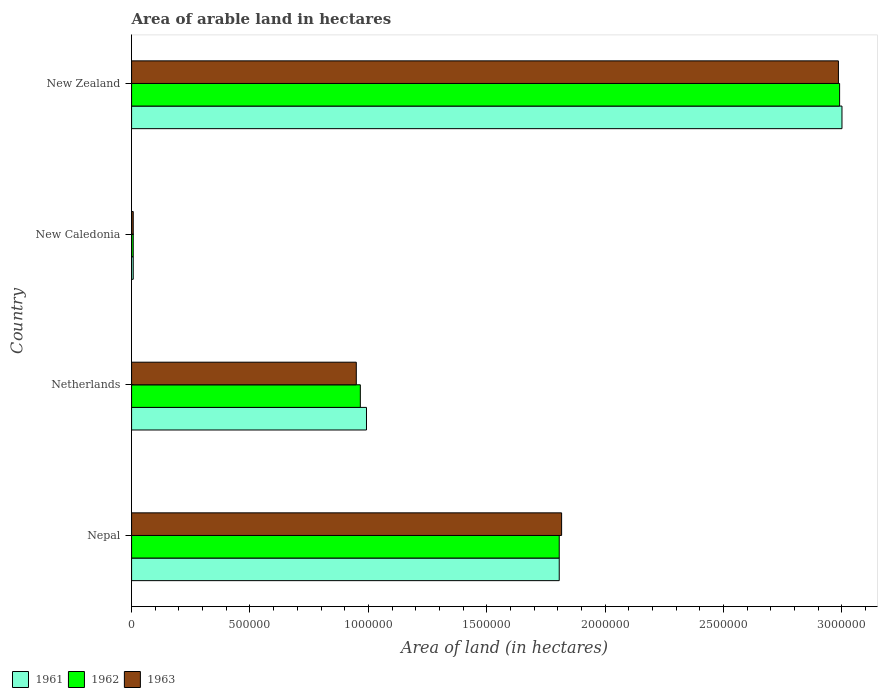What is the label of the 2nd group of bars from the top?
Give a very brief answer. New Caledonia. In how many cases, is the number of bars for a given country not equal to the number of legend labels?
Ensure brevity in your answer.  0. What is the total arable land in 1963 in Nepal?
Your response must be concise. 1.82e+06. Across all countries, what is the minimum total arable land in 1962?
Offer a very short reply. 7000. In which country was the total arable land in 1963 maximum?
Give a very brief answer. New Zealand. In which country was the total arable land in 1963 minimum?
Ensure brevity in your answer.  New Caledonia. What is the total total arable land in 1963 in the graph?
Provide a succinct answer. 5.76e+06. What is the difference between the total arable land in 1962 in Nepal and that in New Zealand?
Your answer should be compact. -1.18e+06. What is the difference between the total arable land in 1963 in Netherlands and the total arable land in 1961 in New Caledonia?
Keep it short and to the point. 9.42e+05. What is the average total arable land in 1962 per country?
Your answer should be very brief. 1.44e+06. What is the difference between the total arable land in 1961 and total arable land in 1963 in Nepal?
Keep it short and to the point. -10000. What is the ratio of the total arable land in 1963 in Netherlands to that in New Caledonia?
Keep it short and to the point. 135.57. Is the total arable land in 1963 in New Caledonia less than that in New Zealand?
Offer a terse response. Yes. What is the difference between the highest and the second highest total arable land in 1962?
Make the answer very short. 1.18e+06. What is the difference between the highest and the lowest total arable land in 1963?
Provide a succinct answer. 2.98e+06. Is the sum of the total arable land in 1961 in Netherlands and New Caledonia greater than the maximum total arable land in 1963 across all countries?
Ensure brevity in your answer.  No. What does the 1st bar from the top in Nepal represents?
Your answer should be compact. 1963. How many bars are there?
Provide a short and direct response. 12. How many countries are there in the graph?
Provide a succinct answer. 4. Does the graph contain grids?
Ensure brevity in your answer.  No. How many legend labels are there?
Keep it short and to the point. 3. How are the legend labels stacked?
Your response must be concise. Horizontal. What is the title of the graph?
Offer a terse response. Area of arable land in hectares. What is the label or title of the X-axis?
Provide a short and direct response. Area of land (in hectares). What is the label or title of the Y-axis?
Your answer should be compact. Country. What is the Area of land (in hectares) of 1961 in Nepal?
Provide a succinct answer. 1.81e+06. What is the Area of land (in hectares) in 1962 in Nepal?
Keep it short and to the point. 1.81e+06. What is the Area of land (in hectares) of 1963 in Nepal?
Offer a terse response. 1.82e+06. What is the Area of land (in hectares) of 1961 in Netherlands?
Give a very brief answer. 9.92e+05. What is the Area of land (in hectares) of 1962 in Netherlands?
Provide a succinct answer. 9.66e+05. What is the Area of land (in hectares) in 1963 in Netherlands?
Offer a very short reply. 9.49e+05. What is the Area of land (in hectares) of 1961 in New Caledonia?
Make the answer very short. 7000. What is the Area of land (in hectares) of 1962 in New Caledonia?
Keep it short and to the point. 7000. What is the Area of land (in hectares) of 1963 in New Caledonia?
Provide a succinct answer. 7000. What is the Area of land (in hectares) in 1961 in New Zealand?
Keep it short and to the point. 3.00e+06. What is the Area of land (in hectares) of 1962 in New Zealand?
Give a very brief answer. 2.99e+06. What is the Area of land (in hectares) of 1963 in New Zealand?
Your answer should be very brief. 2.98e+06. Across all countries, what is the maximum Area of land (in hectares) of 1962?
Offer a very short reply. 2.99e+06. Across all countries, what is the maximum Area of land (in hectares) in 1963?
Give a very brief answer. 2.98e+06. Across all countries, what is the minimum Area of land (in hectares) of 1961?
Make the answer very short. 7000. Across all countries, what is the minimum Area of land (in hectares) of 1962?
Ensure brevity in your answer.  7000. Across all countries, what is the minimum Area of land (in hectares) of 1963?
Make the answer very short. 7000. What is the total Area of land (in hectares) in 1961 in the graph?
Provide a short and direct response. 5.80e+06. What is the total Area of land (in hectares) in 1962 in the graph?
Offer a terse response. 5.77e+06. What is the total Area of land (in hectares) of 1963 in the graph?
Ensure brevity in your answer.  5.76e+06. What is the difference between the Area of land (in hectares) of 1961 in Nepal and that in Netherlands?
Your response must be concise. 8.14e+05. What is the difference between the Area of land (in hectares) of 1962 in Nepal and that in Netherlands?
Offer a very short reply. 8.40e+05. What is the difference between the Area of land (in hectares) in 1963 in Nepal and that in Netherlands?
Your answer should be very brief. 8.67e+05. What is the difference between the Area of land (in hectares) in 1961 in Nepal and that in New Caledonia?
Provide a short and direct response. 1.80e+06. What is the difference between the Area of land (in hectares) in 1962 in Nepal and that in New Caledonia?
Give a very brief answer. 1.80e+06. What is the difference between the Area of land (in hectares) in 1963 in Nepal and that in New Caledonia?
Provide a succinct answer. 1.81e+06. What is the difference between the Area of land (in hectares) of 1961 in Nepal and that in New Zealand?
Keep it short and to the point. -1.19e+06. What is the difference between the Area of land (in hectares) in 1962 in Nepal and that in New Zealand?
Offer a very short reply. -1.18e+06. What is the difference between the Area of land (in hectares) in 1963 in Nepal and that in New Zealand?
Your answer should be very brief. -1.17e+06. What is the difference between the Area of land (in hectares) in 1961 in Netherlands and that in New Caledonia?
Your answer should be compact. 9.85e+05. What is the difference between the Area of land (in hectares) in 1962 in Netherlands and that in New Caledonia?
Ensure brevity in your answer.  9.59e+05. What is the difference between the Area of land (in hectares) of 1963 in Netherlands and that in New Caledonia?
Your answer should be compact. 9.42e+05. What is the difference between the Area of land (in hectares) of 1961 in Netherlands and that in New Zealand?
Your response must be concise. -2.01e+06. What is the difference between the Area of land (in hectares) in 1962 in Netherlands and that in New Zealand?
Give a very brief answer. -2.02e+06. What is the difference between the Area of land (in hectares) in 1963 in Netherlands and that in New Zealand?
Ensure brevity in your answer.  -2.04e+06. What is the difference between the Area of land (in hectares) in 1961 in New Caledonia and that in New Zealand?
Your response must be concise. -2.99e+06. What is the difference between the Area of land (in hectares) in 1962 in New Caledonia and that in New Zealand?
Keep it short and to the point. -2.98e+06. What is the difference between the Area of land (in hectares) in 1963 in New Caledonia and that in New Zealand?
Give a very brief answer. -2.98e+06. What is the difference between the Area of land (in hectares) of 1961 in Nepal and the Area of land (in hectares) of 1962 in Netherlands?
Offer a very short reply. 8.40e+05. What is the difference between the Area of land (in hectares) in 1961 in Nepal and the Area of land (in hectares) in 1963 in Netherlands?
Provide a short and direct response. 8.57e+05. What is the difference between the Area of land (in hectares) of 1962 in Nepal and the Area of land (in hectares) of 1963 in Netherlands?
Provide a succinct answer. 8.57e+05. What is the difference between the Area of land (in hectares) in 1961 in Nepal and the Area of land (in hectares) in 1962 in New Caledonia?
Offer a terse response. 1.80e+06. What is the difference between the Area of land (in hectares) of 1961 in Nepal and the Area of land (in hectares) of 1963 in New Caledonia?
Provide a succinct answer. 1.80e+06. What is the difference between the Area of land (in hectares) of 1962 in Nepal and the Area of land (in hectares) of 1963 in New Caledonia?
Offer a very short reply. 1.80e+06. What is the difference between the Area of land (in hectares) in 1961 in Nepal and the Area of land (in hectares) in 1962 in New Zealand?
Your answer should be very brief. -1.18e+06. What is the difference between the Area of land (in hectares) in 1961 in Nepal and the Area of land (in hectares) in 1963 in New Zealand?
Your response must be concise. -1.18e+06. What is the difference between the Area of land (in hectares) of 1962 in Nepal and the Area of land (in hectares) of 1963 in New Zealand?
Make the answer very short. -1.18e+06. What is the difference between the Area of land (in hectares) in 1961 in Netherlands and the Area of land (in hectares) in 1962 in New Caledonia?
Keep it short and to the point. 9.85e+05. What is the difference between the Area of land (in hectares) of 1961 in Netherlands and the Area of land (in hectares) of 1963 in New Caledonia?
Provide a succinct answer. 9.85e+05. What is the difference between the Area of land (in hectares) of 1962 in Netherlands and the Area of land (in hectares) of 1963 in New Caledonia?
Offer a terse response. 9.59e+05. What is the difference between the Area of land (in hectares) of 1961 in Netherlands and the Area of land (in hectares) of 1962 in New Zealand?
Your response must be concise. -2.00e+06. What is the difference between the Area of land (in hectares) in 1961 in Netherlands and the Area of land (in hectares) in 1963 in New Zealand?
Give a very brief answer. -1.99e+06. What is the difference between the Area of land (in hectares) of 1962 in Netherlands and the Area of land (in hectares) of 1963 in New Zealand?
Offer a very short reply. -2.02e+06. What is the difference between the Area of land (in hectares) of 1961 in New Caledonia and the Area of land (in hectares) of 1962 in New Zealand?
Keep it short and to the point. -2.98e+06. What is the difference between the Area of land (in hectares) in 1961 in New Caledonia and the Area of land (in hectares) in 1963 in New Zealand?
Offer a very short reply. -2.98e+06. What is the difference between the Area of land (in hectares) in 1962 in New Caledonia and the Area of land (in hectares) in 1963 in New Zealand?
Keep it short and to the point. -2.98e+06. What is the average Area of land (in hectares) in 1961 per country?
Keep it short and to the point. 1.45e+06. What is the average Area of land (in hectares) in 1962 per country?
Give a very brief answer. 1.44e+06. What is the average Area of land (in hectares) of 1963 per country?
Make the answer very short. 1.44e+06. What is the difference between the Area of land (in hectares) in 1961 and Area of land (in hectares) in 1962 in Nepal?
Your response must be concise. 0. What is the difference between the Area of land (in hectares) of 1962 and Area of land (in hectares) of 1963 in Nepal?
Ensure brevity in your answer.  -10000. What is the difference between the Area of land (in hectares) of 1961 and Area of land (in hectares) of 1962 in Netherlands?
Provide a succinct answer. 2.60e+04. What is the difference between the Area of land (in hectares) in 1961 and Area of land (in hectares) in 1963 in Netherlands?
Offer a terse response. 4.30e+04. What is the difference between the Area of land (in hectares) of 1962 and Area of land (in hectares) of 1963 in Netherlands?
Ensure brevity in your answer.  1.70e+04. What is the difference between the Area of land (in hectares) in 1961 and Area of land (in hectares) in 1963 in New Caledonia?
Offer a terse response. 0. What is the difference between the Area of land (in hectares) in 1961 and Area of land (in hectares) in 1962 in New Zealand?
Your answer should be very brief. 10000. What is the difference between the Area of land (in hectares) in 1961 and Area of land (in hectares) in 1963 in New Zealand?
Offer a terse response. 1.50e+04. What is the difference between the Area of land (in hectares) in 1962 and Area of land (in hectares) in 1963 in New Zealand?
Your answer should be compact. 5000. What is the ratio of the Area of land (in hectares) in 1961 in Nepal to that in Netherlands?
Offer a very short reply. 1.82. What is the ratio of the Area of land (in hectares) in 1962 in Nepal to that in Netherlands?
Provide a succinct answer. 1.87. What is the ratio of the Area of land (in hectares) in 1963 in Nepal to that in Netherlands?
Keep it short and to the point. 1.91. What is the ratio of the Area of land (in hectares) of 1961 in Nepal to that in New Caledonia?
Offer a very short reply. 258. What is the ratio of the Area of land (in hectares) in 1962 in Nepal to that in New Caledonia?
Your answer should be compact. 258. What is the ratio of the Area of land (in hectares) of 1963 in Nepal to that in New Caledonia?
Ensure brevity in your answer.  259.43. What is the ratio of the Area of land (in hectares) in 1961 in Nepal to that in New Zealand?
Your response must be concise. 0.6. What is the ratio of the Area of land (in hectares) in 1962 in Nepal to that in New Zealand?
Provide a succinct answer. 0.6. What is the ratio of the Area of land (in hectares) in 1963 in Nepal to that in New Zealand?
Provide a short and direct response. 0.61. What is the ratio of the Area of land (in hectares) in 1961 in Netherlands to that in New Caledonia?
Offer a very short reply. 141.71. What is the ratio of the Area of land (in hectares) in 1962 in Netherlands to that in New Caledonia?
Ensure brevity in your answer.  138. What is the ratio of the Area of land (in hectares) in 1963 in Netherlands to that in New Caledonia?
Your answer should be compact. 135.57. What is the ratio of the Area of land (in hectares) of 1961 in Netherlands to that in New Zealand?
Provide a succinct answer. 0.33. What is the ratio of the Area of land (in hectares) in 1962 in Netherlands to that in New Zealand?
Offer a very short reply. 0.32. What is the ratio of the Area of land (in hectares) in 1963 in Netherlands to that in New Zealand?
Offer a terse response. 0.32. What is the ratio of the Area of land (in hectares) of 1961 in New Caledonia to that in New Zealand?
Give a very brief answer. 0. What is the ratio of the Area of land (in hectares) in 1962 in New Caledonia to that in New Zealand?
Make the answer very short. 0. What is the ratio of the Area of land (in hectares) in 1963 in New Caledonia to that in New Zealand?
Your answer should be compact. 0. What is the difference between the highest and the second highest Area of land (in hectares) of 1961?
Provide a succinct answer. 1.19e+06. What is the difference between the highest and the second highest Area of land (in hectares) in 1962?
Offer a terse response. 1.18e+06. What is the difference between the highest and the second highest Area of land (in hectares) of 1963?
Offer a terse response. 1.17e+06. What is the difference between the highest and the lowest Area of land (in hectares) in 1961?
Your answer should be very brief. 2.99e+06. What is the difference between the highest and the lowest Area of land (in hectares) in 1962?
Ensure brevity in your answer.  2.98e+06. What is the difference between the highest and the lowest Area of land (in hectares) of 1963?
Give a very brief answer. 2.98e+06. 